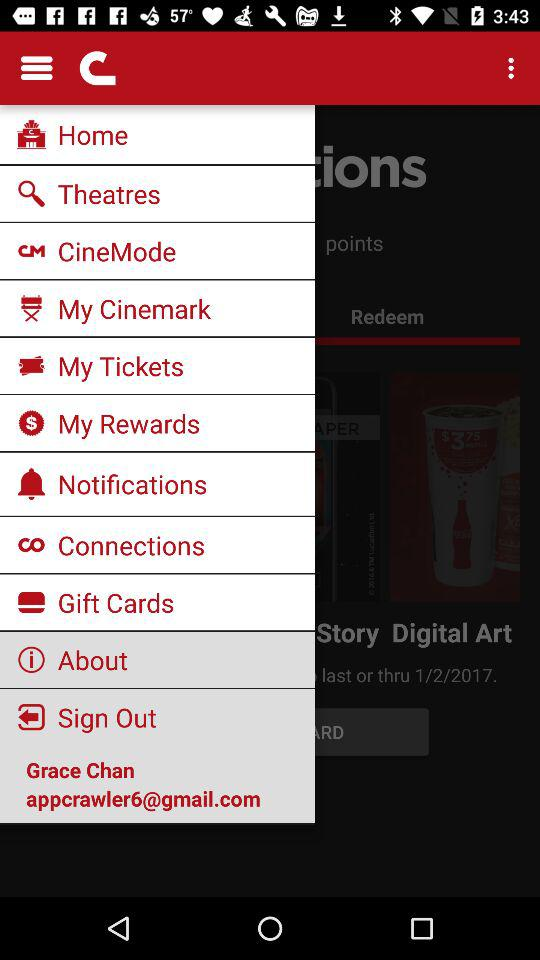What is the email address? The email address is appcrawler6@gmail.com. 